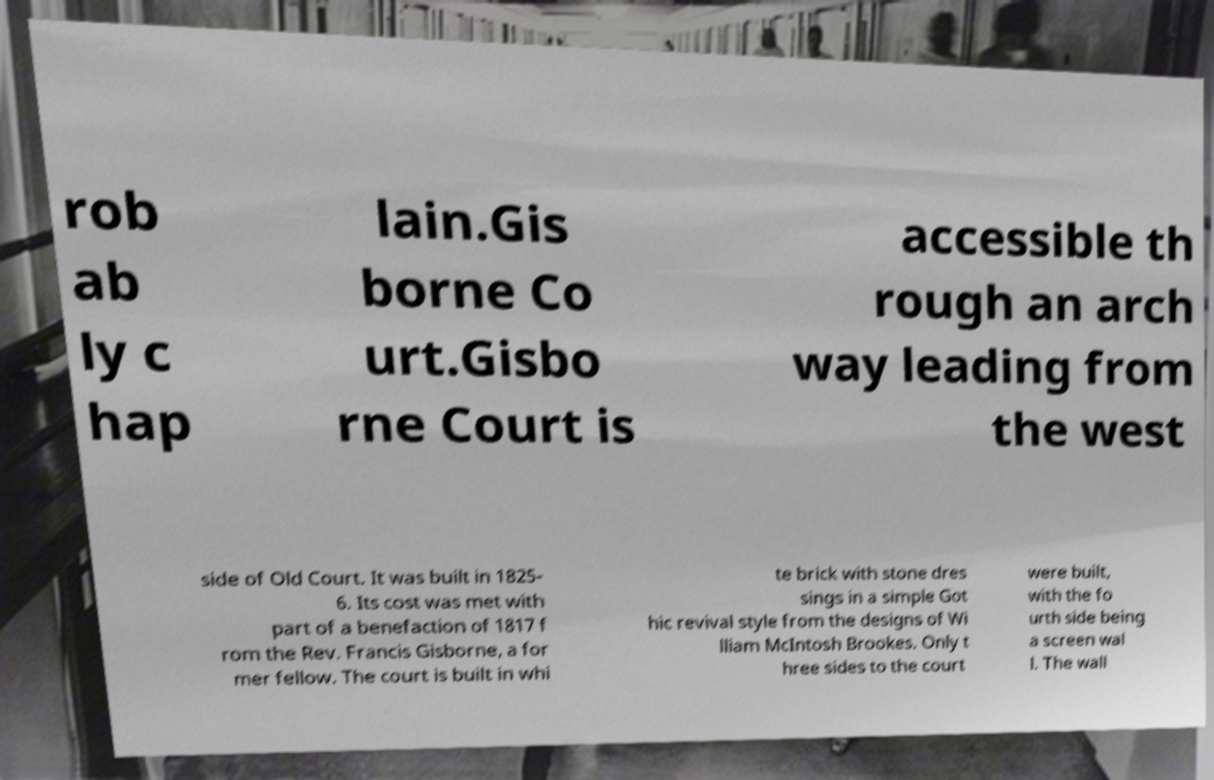There's text embedded in this image that I need extracted. Can you transcribe it verbatim? rob ab ly c hap lain.Gis borne Co urt.Gisbo rne Court is accessible th rough an arch way leading from the west side of Old Court. It was built in 1825- 6. Its cost was met with part of a benefaction of 1817 f rom the Rev. Francis Gisborne, a for mer fellow. The court is built in whi te brick with stone dres sings in a simple Got hic revival style from the designs of Wi lliam McIntosh Brookes. Only t hree sides to the court were built, with the fo urth side being a screen wal l. The wall 